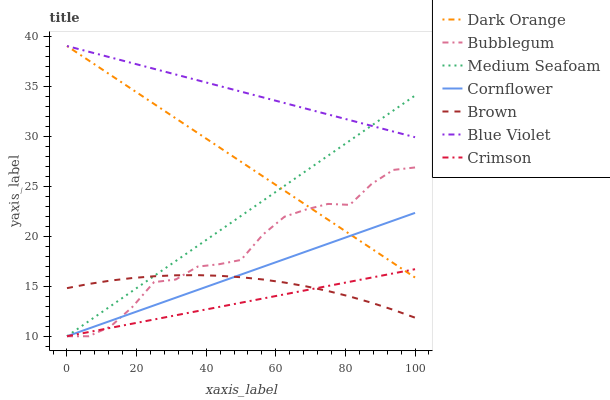Does Crimson have the minimum area under the curve?
Answer yes or no. Yes. Does Blue Violet have the maximum area under the curve?
Answer yes or no. Yes. Does Dark Orange have the minimum area under the curve?
Answer yes or no. No. Does Dark Orange have the maximum area under the curve?
Answer yes or no. No. Is Dark Orange the smoothest?
Answer yes or no. Yes. Is Bubblegum the roughest?
Answer yes or no. Yes. Is Bubblegum the smoothest?
Answer yes or no. No. Is Dark Orange the roughest?
Answer yes or no. No. Does Dark Orange have the lowest value?
Answer yes or no. No. Does Bubblegum have the highest value?
Answer yes or no. No. Is Bubblegum less than Blue Violet?
Answer yes or no. Yes. Is Blue Violet greater than Crimson?
Answer yes or no. Yes. Does Bubblegum intersect Blue Violet?
Answer yes or no. No. 